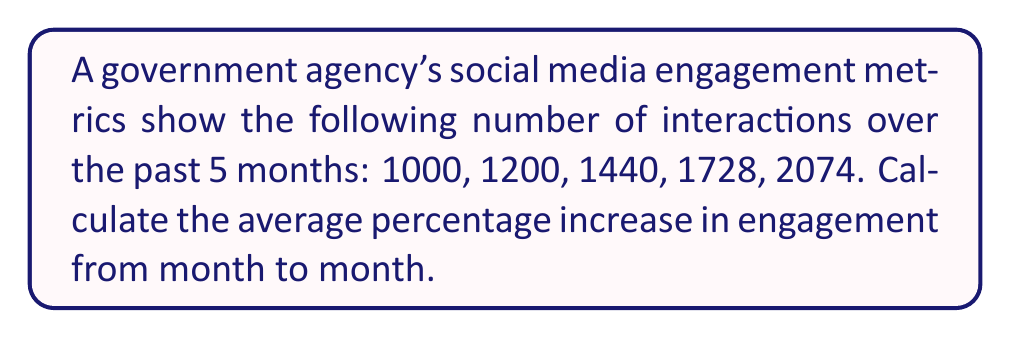What is the answer to this math problem? To solve this problem, we'll follow these steps:

1) Calculate the percentage increase for each month:

   Month 1 to 2: $\frac{1200 - 1000}{1000} \times 100\% = 20\%$
   Month 2 to 3: $\frac{1440 - 1200}{1200} \times 100\% = 20\%$
   Month 3 to 4: $\frac{1728 - 1440}{1440} \times 100\% = 20\%$
   Month 4 to 5: $\frac{2074 - 1728}{1728} \times 100\% = 20\%$

2) Calculate the average of these percentages:

   $\frac{20\% + 20\% + 20\% + 20\%}{4} = 20\%$

Alternatively, we can use the compound growth formula:

$$\text{Growth Rate} = \left(\frac{\text{Final Value}}{\text{Initial Value}}\right)^{\frac{1}{n}} - 1$$

Where $n$ is the number of periods (4 in this case).

$$\text{Growth Rate} = \left(\frac{2074}{1000}\right)^{\frac{1}{4}} - 1 = 1.2 - 1 = 0.2 = 20\%$$

Both methods yield the same result: an average 20% increase per month.
Answer: 20% 